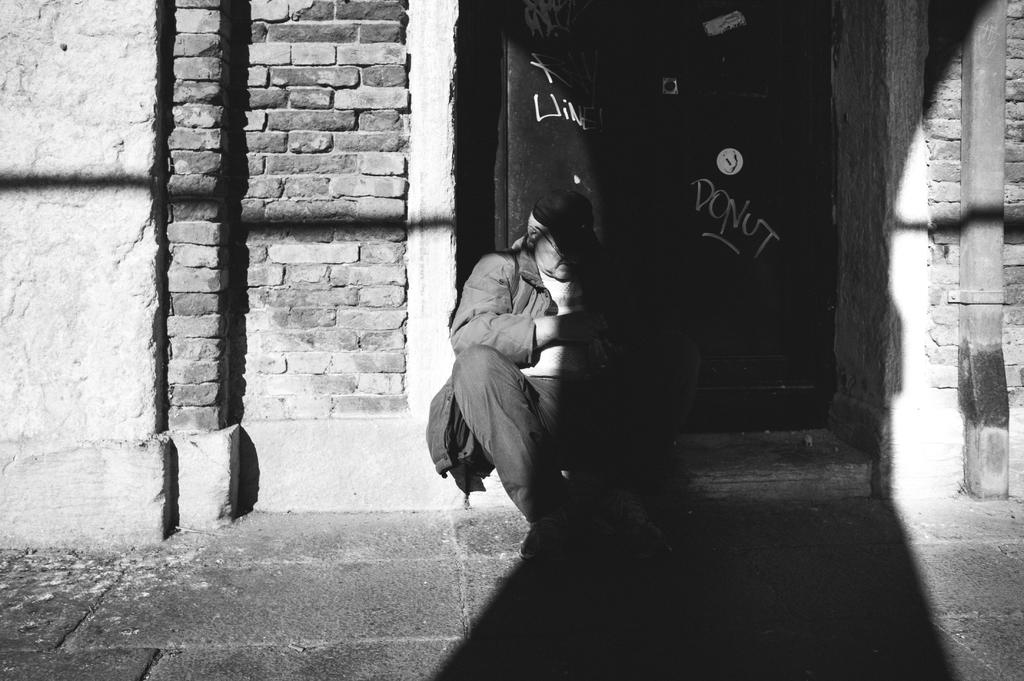What is the position of the person in the image? The person is seated in the image. Where is the person seated in relation to other objects in the image? The person is seated in front of a door. What type of wall is visible in the image? There is a brick wall in the image. How many houses are visible in the image? There are no houses visible in the image; only a brick wall is present. 